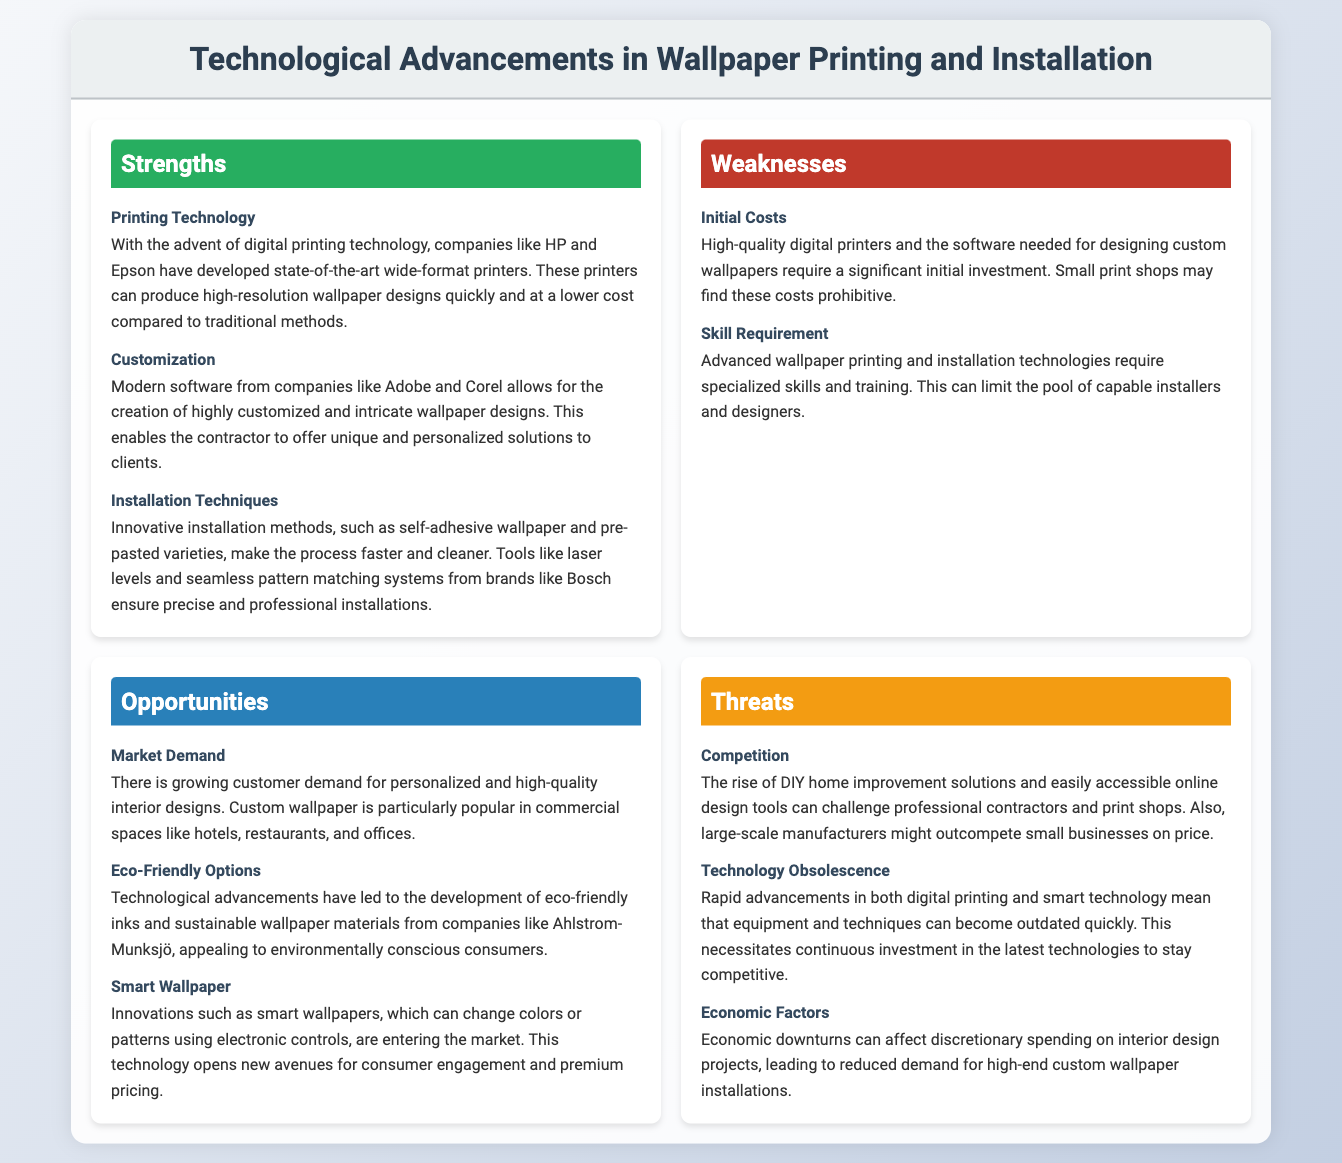what is the title of the document? The title of the document can be found at the top section, indicating its subject matter.
Answer: Technological Advancements in Wallpaper Printing and Installation who are the notable companies mentioned for printing technology? The document lists companies that have developed advanced printing technology, specifically in the strengths section.
Answer: HP and Epson what is one of the weaknesses related to costs? The weaknesses section highlights issues regarding expenses associated with technology and equipment.
Answer: Initial Costs what opportunity is related to consumer preferences? The document points out customer trends and market demand related to wallpaper design options.
Answer: Market Demand name one eco-friendly material company mentioned. The opportunities section lists a company that provides sustainable wallpaper materials, which relates to eco-friendly options.
Answer: Ahlstrom-Munksjö what type of wallpaper innovation is discussed as a potential market trend? The document discusses a new technological development in wallpaper that introduces interaction and customization.
Answer: Smart Wallpaper which aspect of competition poses a threat to contractors? The threats section addresses challenges that arise from market competition related to DIY solutions and pricing.
Answer: Competition what is a skill requirement mentioned in the weaknesses? The weaknesses section specifies a necessity for expertise in handling advanced technology relevant to the business.
Answer: Skill Requirement 